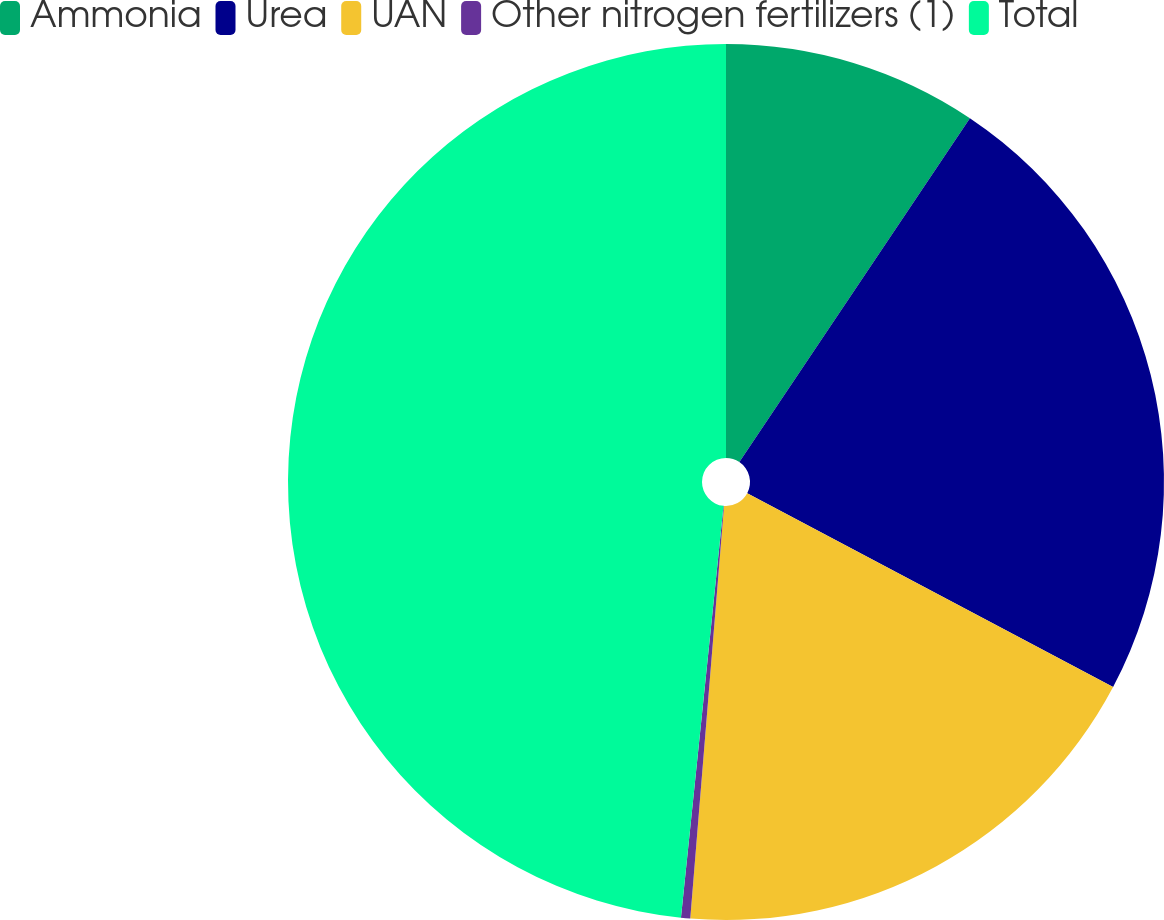Convert chart. <chart><loc_0><loc_0><loc_500><loc_500><pie_chart><fcel>Ammonia<fcel>Urea<fcel>UAN<fcel>Other nitrogen fertilizers (1)<fcel>Total<nl><fcel>9.4%<fcel>23.35%<fcel>18.55%<fcel>0.34%<fcel>48.36%<nl></chart> 